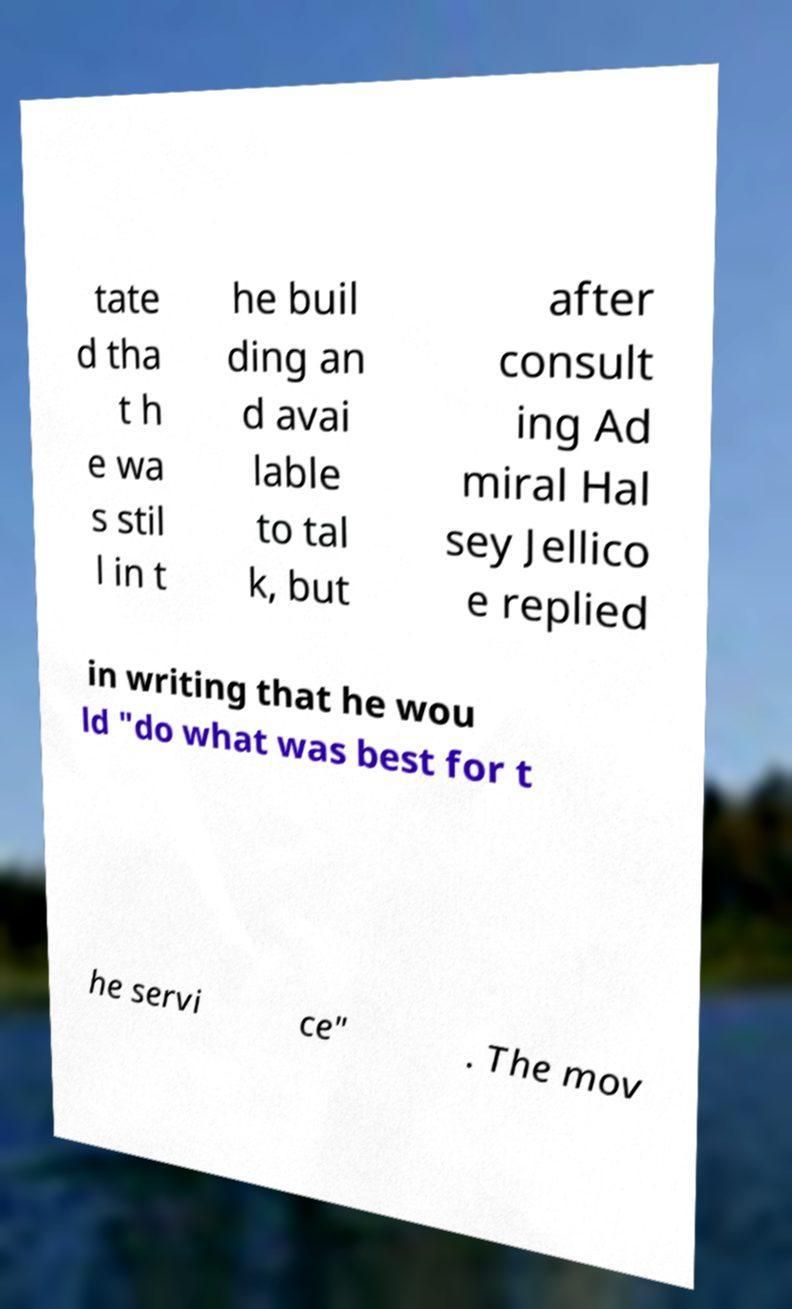Can you accurately transcribe the text from the provided image for me? tate d tha t h e wa s stil l in t he buil ding an d avai lable to tal k, but after consult ing Ad miral Hal sey Jellico e replied in writing that he wou ld "do what was best for t he servi ce" . The mov 